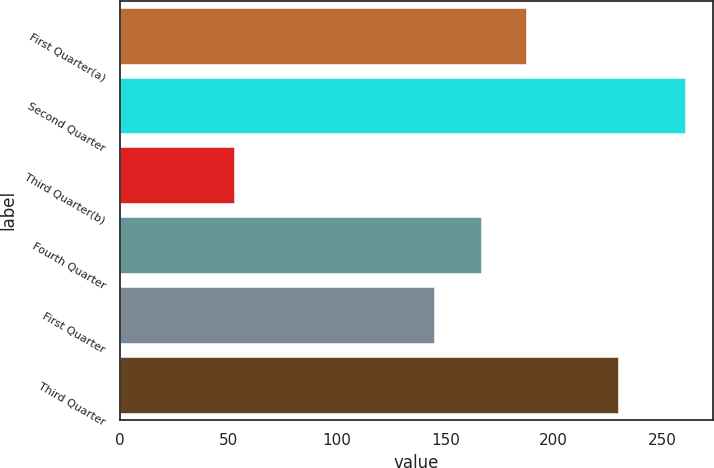Convert chart to OTSL. <chart><loc_0><loc_0><loc_500><loc_500><bar_chart><fcel>First Quarter(a)<fcel>Second Quarter<fcel>Third Quarter(b)<fcel>Fourth Quarter<fcel>First Quarter<fcel>Third Quarter<nl><fcel>187.37<fcel>260.3<fcel>52.6<fcel>166.6<fcel>144.9<fcel>229.4<nl></chart> 